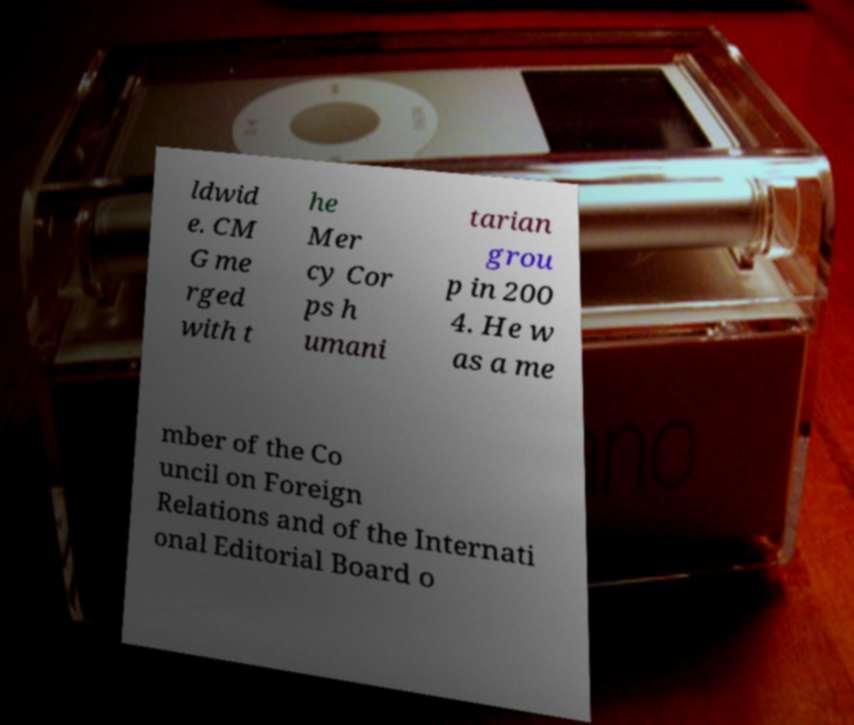I need the written content from this picture converted into text. Can you do that? ldwid e. CM G me rged with t he Mer cy Cor ps h umani tarian grou p in 200 4. He w as a me mber of the Co uncil on Foreign Relations and of the Internati onal Editorial Board o 